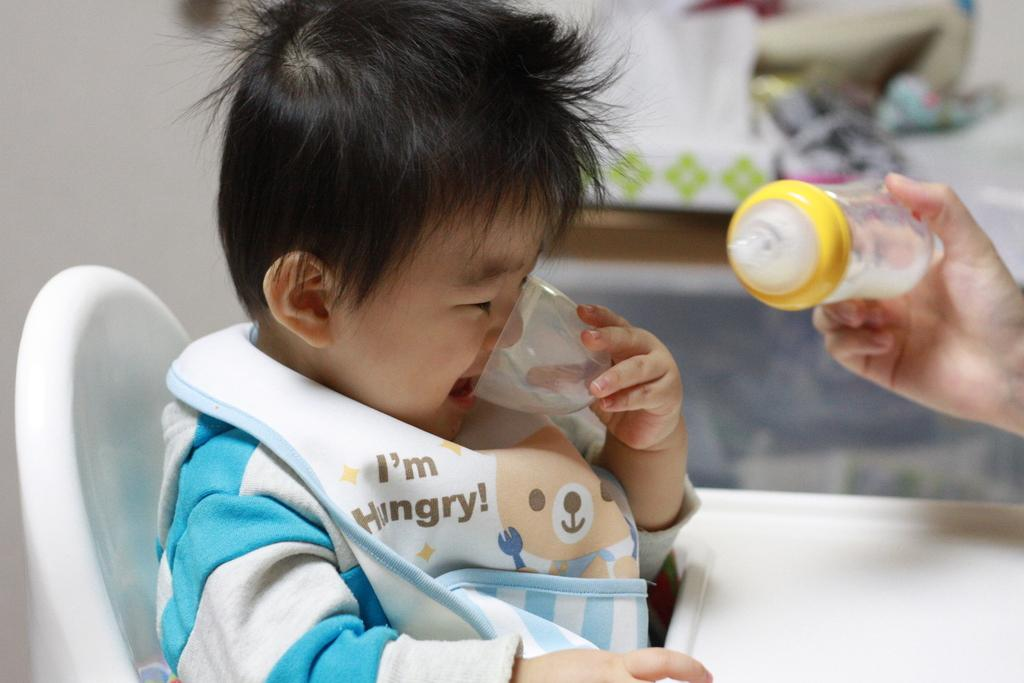<image>
Give a short and clear explanation of the subsequent image. A toddler is drinking from a cup while a bottle is offered to him. 